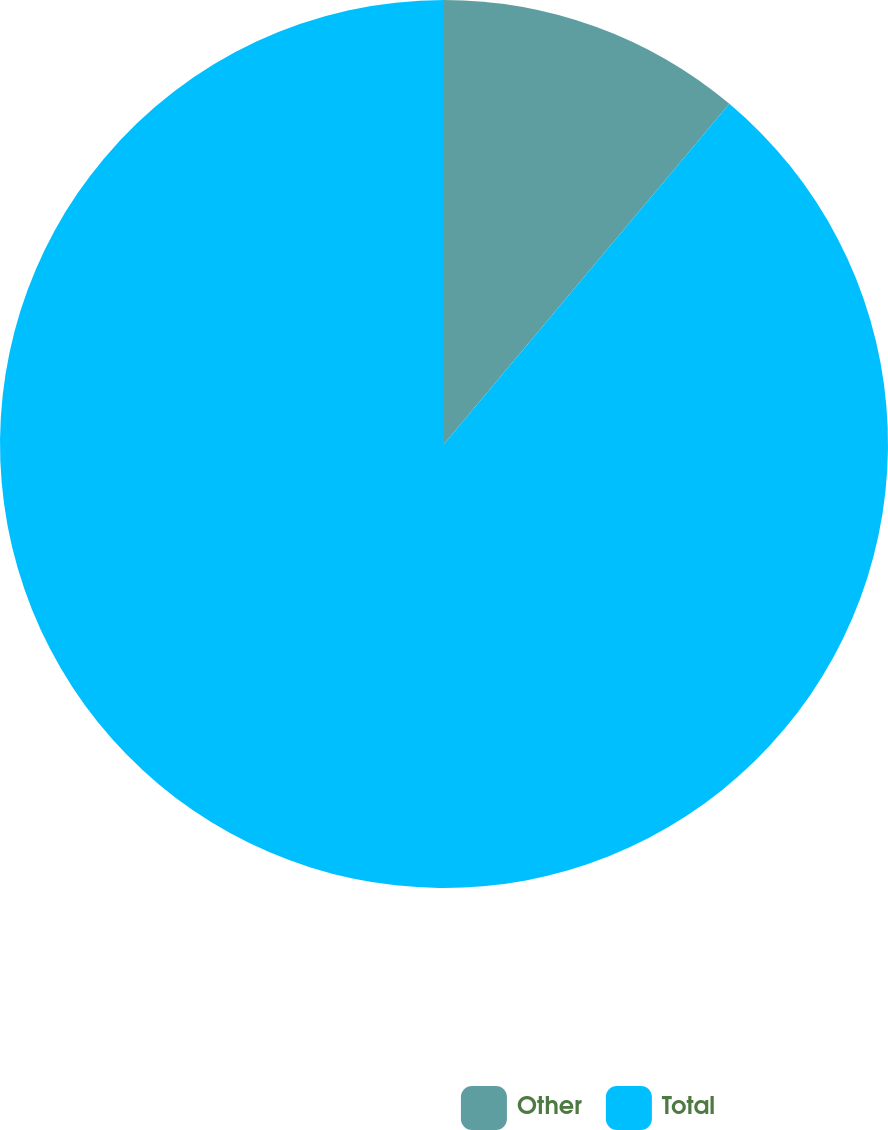Convert chart to OTSL. <chart><loc_0><loc_0><loc_500><loc_500><pie_chart><fcel>Other<fcel>Total<nl><fcel>11.11%<fcel>88.89%<nl></chart> 